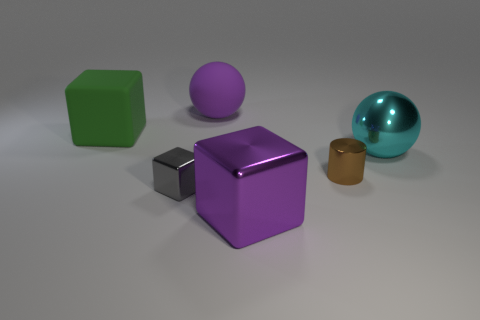Subtract all rubber blocks. How many blocks are left? 2 Subtract all cylinders. How many objects are left? 5 Subtract all cyan spheres. How many spheres are left? 1 Add 4 brown things. How many objects exist? 10 Subtract all purple cylinders. Subtract all purple things. How many objects are left? 4 Add 2 cyan things. How many cyan things are left? 3 Add 4 big red cylinders. How many big red cylinders exist? 4 Subtract 0 cyan blocks. How many objects are left? 6 Subtract all yellow spheres. Subtract all purple cubes. How many spheres are left? 2 Subtract all green cylinders. How many purple cubes are left? 1 